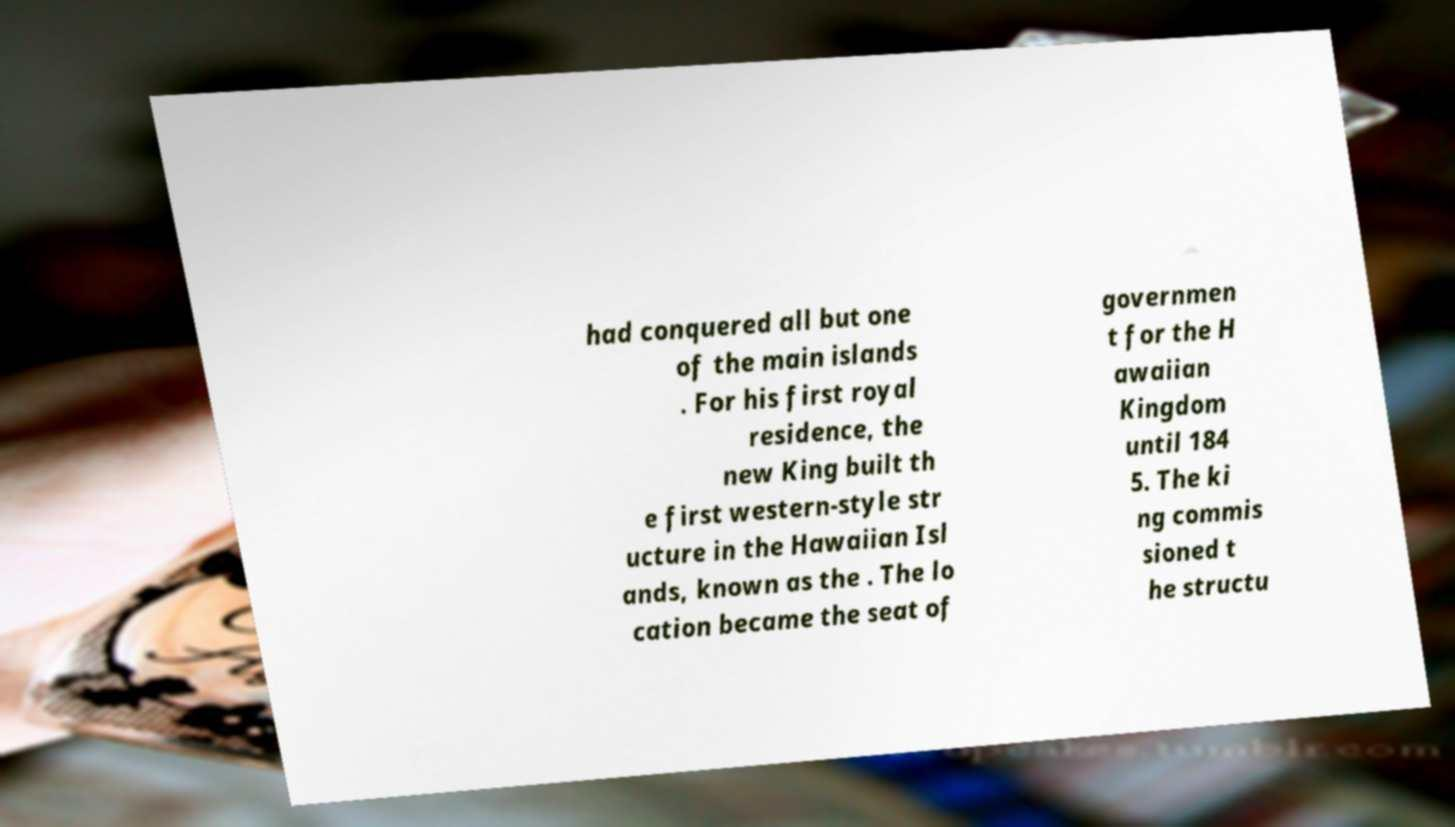Can you accurately transcribe the text from the provided image for me? had conquered all but one of the main islands . For his first royal residence, the new King built th e first western-style str ucture in the Hawaiian Isl ands, known as the . The lo cation became the seat of governmen t for the H awaiian Kingdom until 184 5. The ki ng commis sioned t he structu 